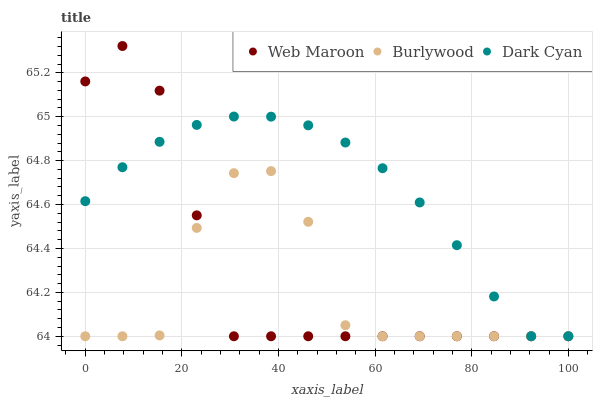Does Burlywood have the minimum area under the curve?
Answer yes or no. Yes. Does Dark Cyan have the maximum area under the curve?
Answer yes or no. Yes. Does Web Maroon have the minimum area under the curve?
Answer yes or no. No. Does Web Maroon have the maximum area under the curve?
Answer yes or no. No. Is Dark Cyan the smoothest?
Answer yes or no. Yes. Is Burlywood the roughest?
Answer yes or no. Yes. Is Web Maroon the smoothest?
Answer yes or no. No. Is Web Maroon the roughest?
Answer yes or no. No. Does Burlywood have the lowest value?
Answer yes or no. Yes. Does Web Maroon have the highest value?
Answer yes or no. Yes. Does Dark Cyan have the highest value?
Answer yes or no. No. Does Web Maroon intersect Dark Cyan?
Answer yes or no. Yes. Is Web Maroon less than Dark Cyan?
Answer yes or no. No. Is Web Maroon greater than Dark Cyan?
Answer yes or no. No. 